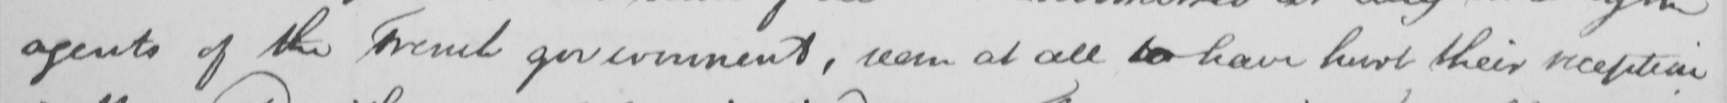Transcribe the text shown in this historical manuscript line. agents of the French government , seem at all to have hurt their reception 